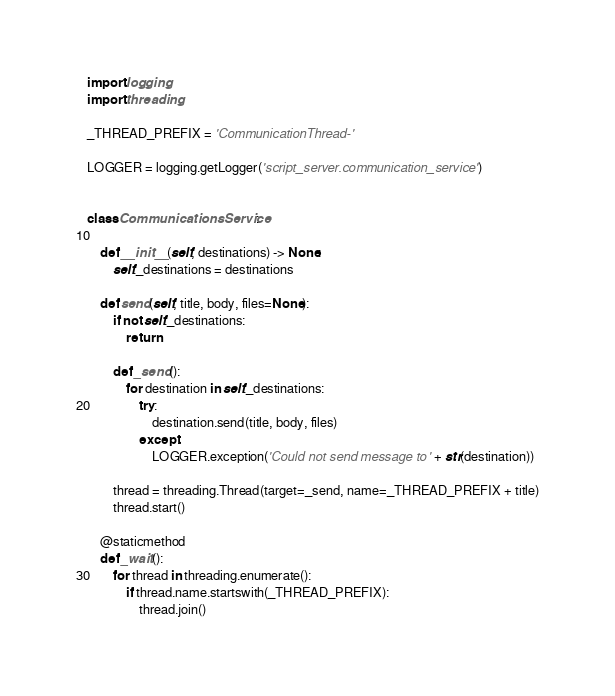Convert code to text. <code><loc_0><loc_0><loc_500><loc_500><_Python_>import logging
import threading

_THREAD_PREFIX = 'CommunicationThread-'

LOGGER = logging.getLogger('script_server.communication_service')


class CommunicationsService:

    def __init__(self, destinations) -> None:
        self._destinations = destinations

    def send(self, title, body, files=None):
        if not self._destinations:
            return

        def _send():
            for destination in self._destinations:
                try:
                    destination.send(title, body, files)
                except:
                    LOGGER.exception('Could not send message to ' + str(destination))

        thread = threading.Thread(target=_send, name=_THREAD_PREFIX + title)
        thread.start()

    @staticmethod
    def _wait():
        for thread in threading.enumerate():
            if thread.name.startswith(_THREAD_PREFIX):
                thread.join()
</code> 